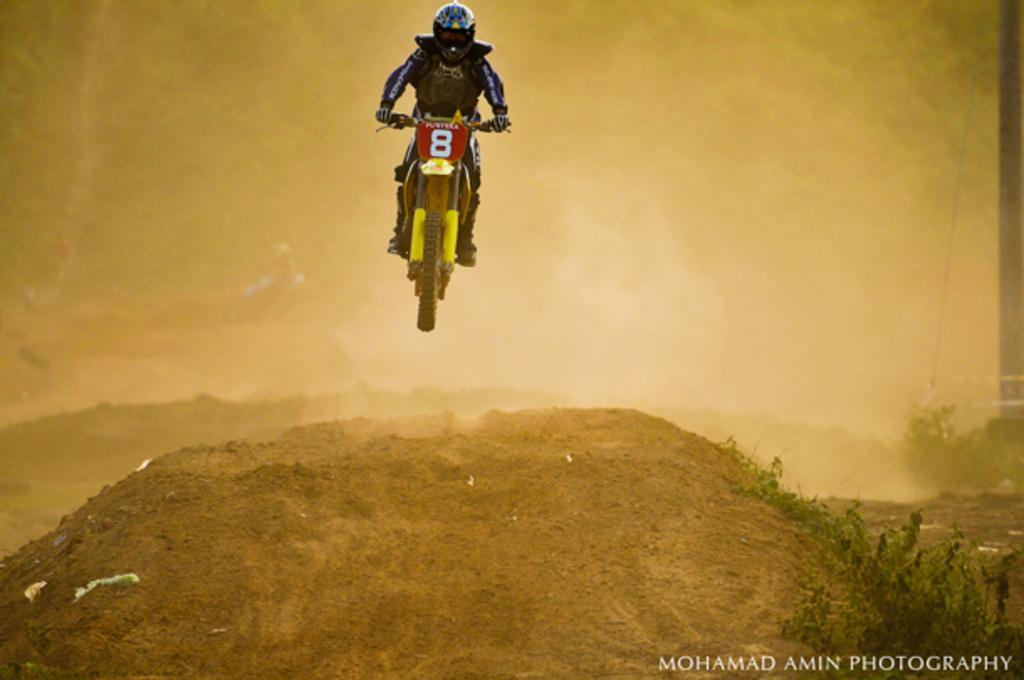In one or two sentences, can you explain what this image depicts? In the center of the image there is a person with bike. At the bottom of the image we can see plants and sand. 